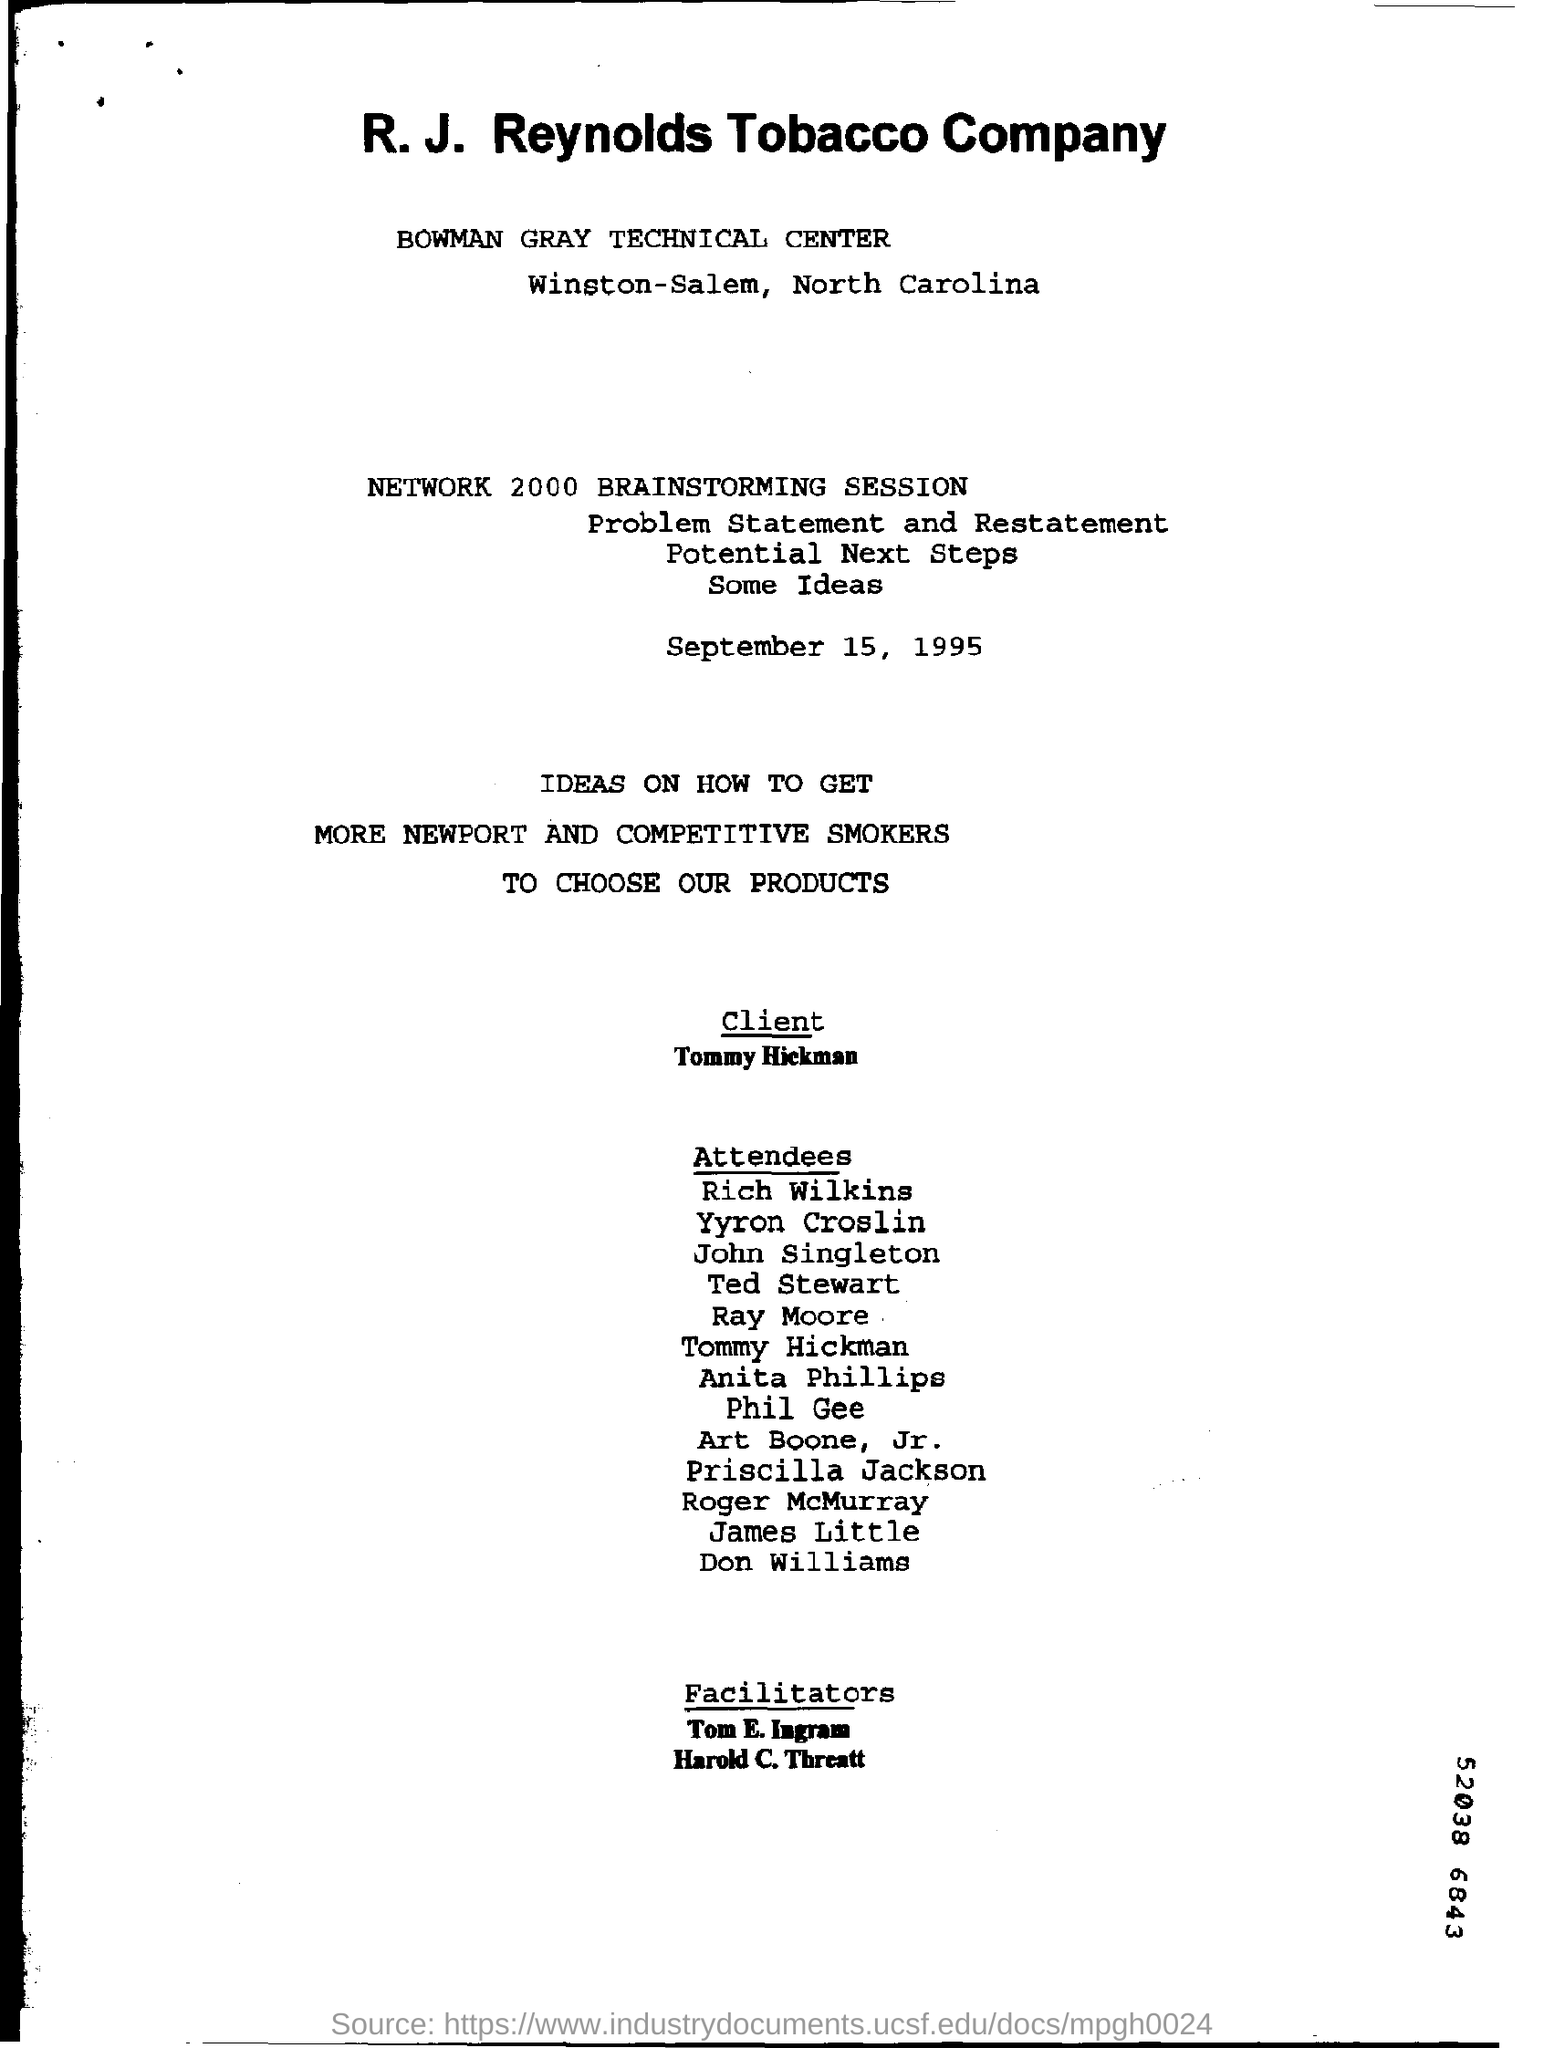List a handful of essential elements in this visual. The company whose name is given in the title is R.J. Reynolds Tobacco Company. The date on which this brainstorming session was held is September 15, 1995. The Bowman Gray Technical Center is located in Winston-Salem, North Carolina. 